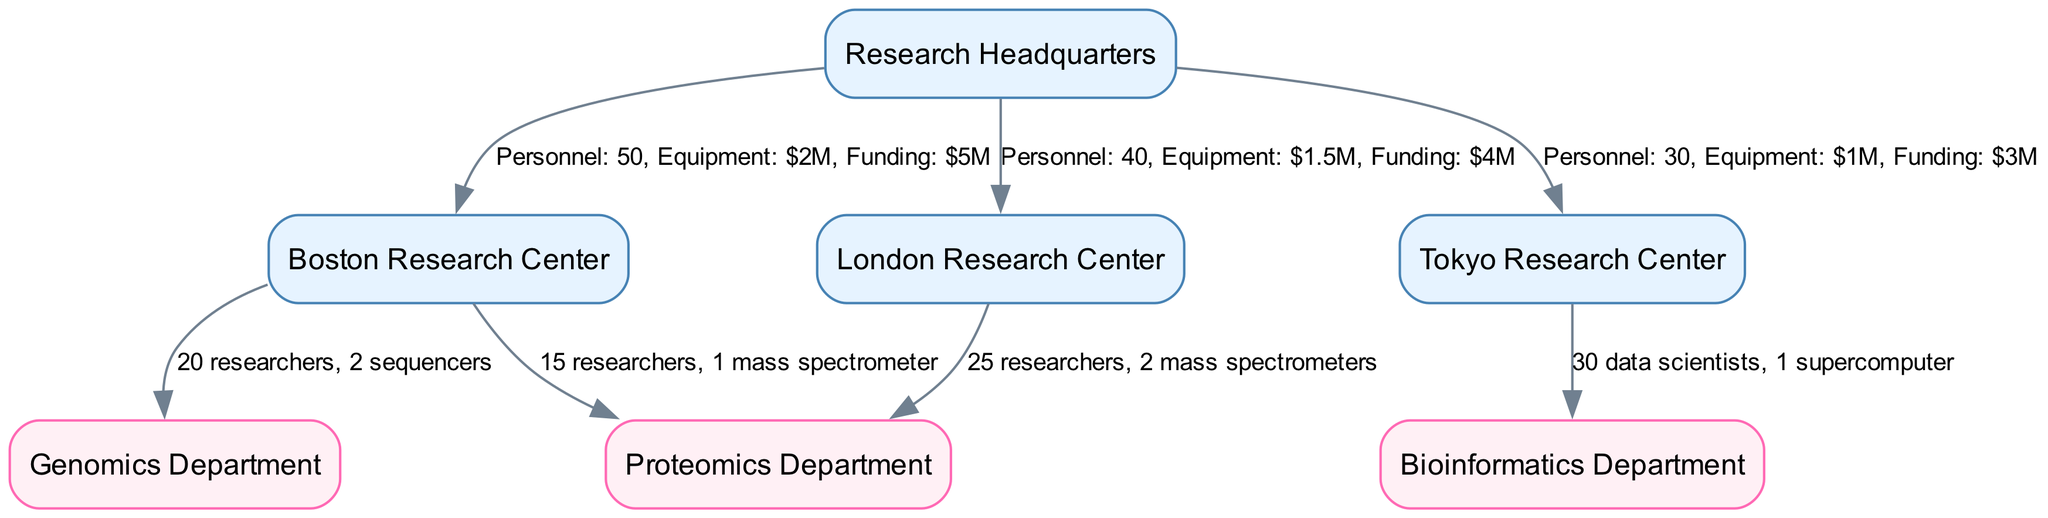What is the total amount of personnel allocated to the Boston Research Center? The diagram shows that the Boston Research Center is allocated 50 personnel, as indicated in the edge connecting HQ to Site1.
Answer: 50 Which department at the Tokyo Research Center has the most personnel? The diagram specifies that the Bioinformatics Department at the Tokyo Research Center has 30 data scientists, and there are no other departments listed at this site for comparison.
Answer: Bioinformatics Department How many equipment units are allocated to the London Research Center? The edge between HQ and Site2 shows that the London Research Center has equipment valued at 1.5 million dollars, specifically detailing the allocation, with no mention of specific equipment units in the diagram.
Answer: $1.5M What is the funding amount for the Boston Research Center? The label on the edge from HQ to Site1 indicates that the Boston Research Center is allocated 5 million dollars in funding.
Answer: $5M How many researchers are at the Genomics Department in Boston? The diagram indicates that at the Boston Research Center, the Genomics Department has 20 researchers, as shown in the edge connecting Site1 to Dept1.
Answer: 20 Which research center has the least funding? By examining the funding allocations for each center—Boston ($5M), London ($4M), and Tokyo ($3M)—it is clear that the Tokyo Research Center has the least funding allocation.
Answer: Tokyo Research Center What is the combined equipment value for both research centers in Boston? The diagram reveals that the Boston Research Center has 2 sequencers and 1 mass spectrometer, when totaled would contribute to the overall equipment allocation, but based on the monetary values, equipment is valued at 2 million dollars.
Answer: $2M How many total divisions are represented in the diagram? The diagram has nodes classified into departments and locations. Counting all the unique locations (4) and departments (3), there are a total of 7 divisions shown.
Answer: 7 Which site has the highest number of mass spectrometers? Based on the diagram, the London Research Center has 2 mass spectrometers, making it the site with the highest count indicated in its connection to the Proteomics Department.
Answer: London Research Center 